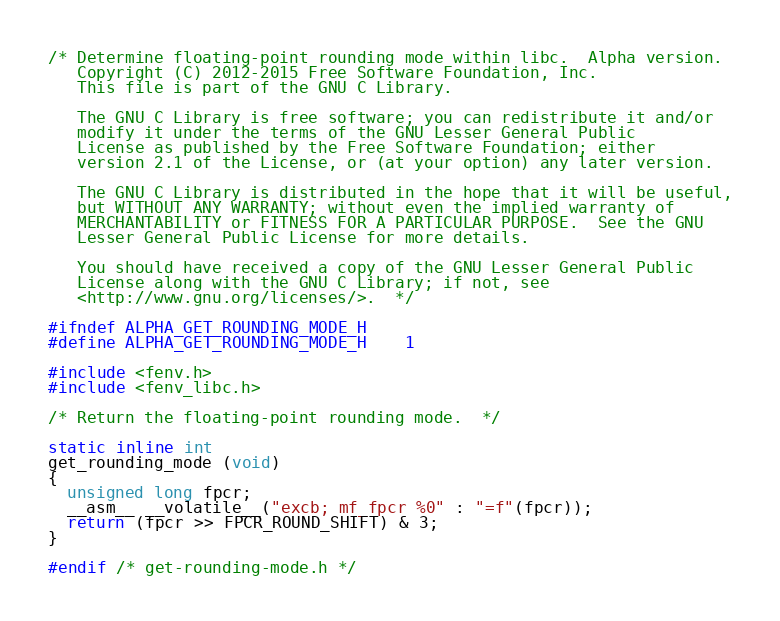<code> <loc_0><loc_0><loc_500><loc_500><_C_>/* Determine floating-point rounding mode within libc.  Alpha version.
   Copyright (C) 2012-2015 Free Software Foundation, Inc.
   This file is part of the GNU C Library.

   The GNU C Library is free software; you can redistribute it and/or
   modify it under the terms of the GNU Lesser General Public
   License as published by the Free Software Foundation; either
   version 2.1 of the License, or (at your option) any later version.

   The GNU C Library is distributed in the hope that it will be useful,
   but WITHOUT ANY WARRANTY; without even the implied warranty of
   MERCHANTABILITY or FITNESS FOR A PARTICULAR PURPOSE.  See the GNU
   Lesser General Public License for more details.

   You should have received a copy of the GNU Lesser General Public
   License along with the GNU C Library; if not, see
   <http://www.gnu.org/licenses/>.  */

#ifndef ALPHA_GET_ROUNDING_MODE_H
#define ALPHA_GET_ROUNDING_MODE_H	1

#include <fenv.h>
#include <fenv_libc.h>

/* Return the floating-point rounding mode.  */

static inline int
get_rounding_mode (void)
{
  unsigned long fpcr;
  __asm__ __volatile__("excb; mf_fpcr %0" : "=f"(fpcr));
  return (fpcr >> FPCR_ROUND_SHIFT) & 3;
}

#endif /* get-rounding-mode.h */
</code> 